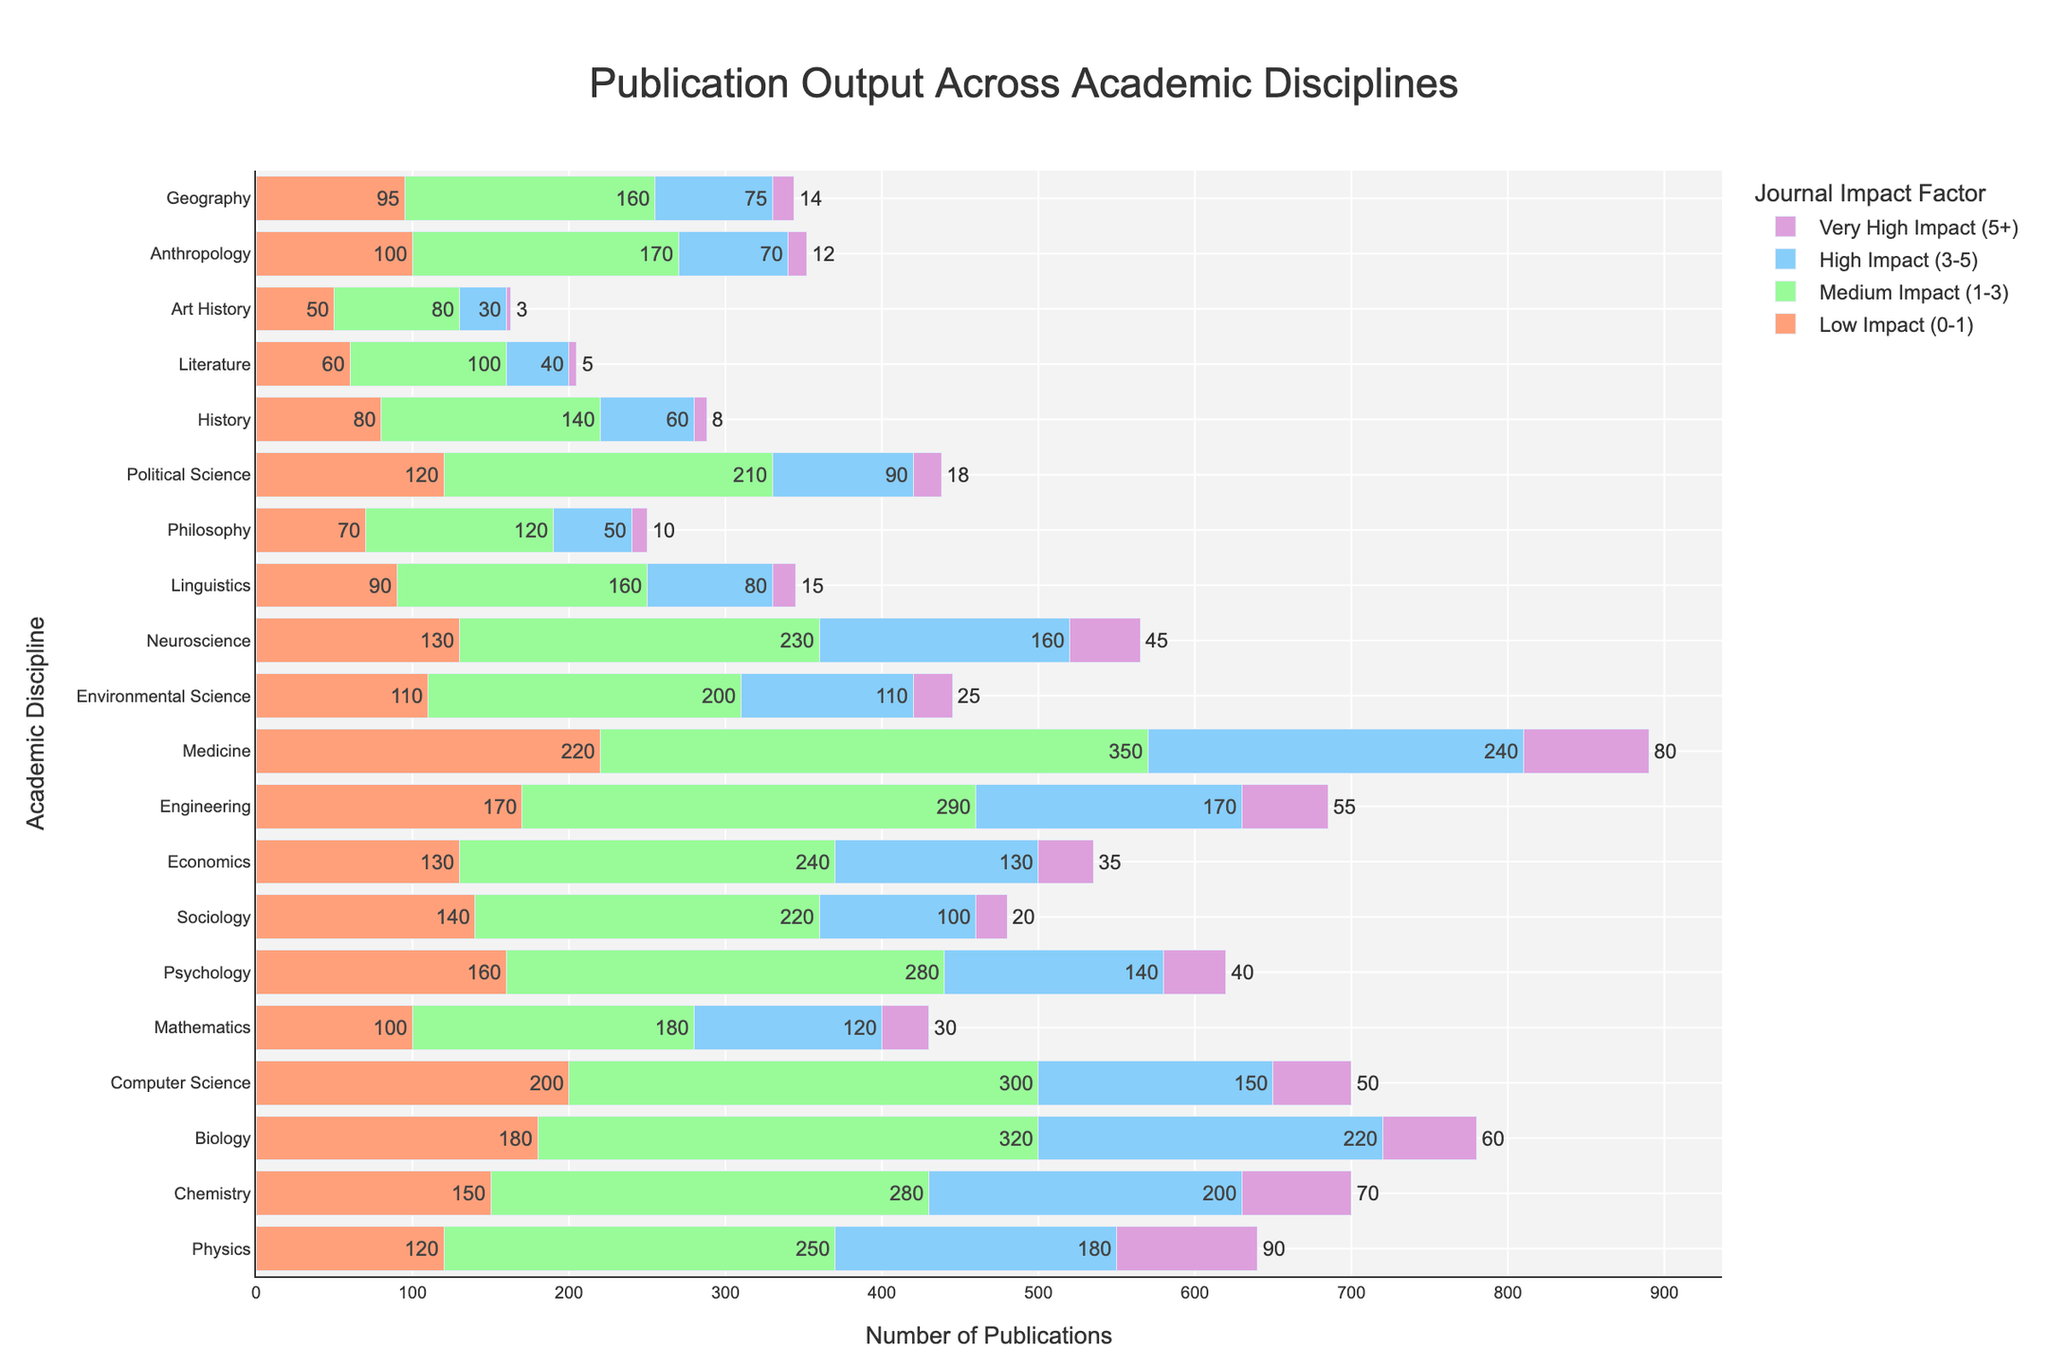What's the academic discipline with the highest total number of publications? To find the academic discipline with the highest total number of publications, sum all the different impact factor categories for each discipline. Medicine has the highest total with 220 (Low Impact) + 350 (Medium Impact) + 240 (High Impact) + 80 (Very High Impact) = 890 publications.
Answer: Medicine Which two disciplines have the closest total number of publications? Sum the total number of publications for each discipline and identify the two with the closest sums. Physics has 120 + 250 + 180 + 90 = 640, and Computer Science has 200 + 300 + 150 + 50 = 700. The difference is 700 - 640 = 60 publications, which is closer than any other pairs.
Answer: Physics and Computer Science What percentage of Neuroscience publications are in high impact factor journals (3-5)? Calculate the proportion of high impact factor publications compared to total publications for Neuroscience: 160 (High Impact) / (130 + 230 + 160 + 45) * 100 = 160 / 565 * 100. Approximately 28.32%.
Answer: Approximately 28.32% Which impact factor category contains the highest number of publications overall? Sum the publications for each impact factor category across all disciplines. Medium Impact (1-3) has the highest total: 250 + 280 + 320 + 300 + 180 + 280 + 220 + 240 + 290 + 350 + 200 + 230 + 160 + 120 + 210 + 140 + 100 + 80 + 170 + 160 = 4960 publications.
Answer: Medium Impact (1-3) In which discipline does the "Very High Impact (5+)" category contribute the highest portion relative to its total publications? Calculate the proportion for each discipline by dividing "Very High Impact (5+)" publications by total publications in that discipline. For example, for Philosophy: 10 / (70 + 120 + 50 + 10) = 10 / 250 = 0.04. Repeat for all disciplines; Art History has the highest portion with 3 / 163 = approximately 0.018.
Answer: Art History Compare the total number of low impact publications (0-1) to high impact publications (3-5) across Medicine. Which category has more? Sum the respective categories for Medicine: 220 (Low Impact) and 240 (High Impact). Compare these sums: 240 (High Impact) is greater than 220 (Low Impact).
Answer: High Impact (3-5) Which discipline has the lowest number of very high impact (5+) publications? Identify the discipline with the lowest value in the "Very High Impact (5+)" category. Art History has the lowest with 3 publications.
Answer: Art History How many publications are there in total for disciplines with more than 200 very high impact publications? Identify disciplines where total of "Very High Impact (5+)" publications is greater than 200 and sum their publications. None of the disciplines have more than 200 publications in this category.
Answer: 0 Between Physics and Chemistry, which discipline has a greater number of medium impact publications (1-3)? Compare the values for medium impact publications: Physics has 250 and Chemistry has 280. Chemistry has more medium impact publications.
Answer: Chemistry What's the overall percentage of low impact (0-1) publications across all disciplines? Calculate the total number of low impact publications and divide by the total number of all publications: (sum of Low Impact (0-1) across all disciplines) / (sum of all categories across all disciplines) * 100. 120 + 150 + 180 + 200 + 100 + 160 + 140 + 130 + 170 + 220 + 110 + 130 + 90 + 70 + 120 + 80 + 60 + 50 + 100 + 95 = 2585 /(2585 + 4960 + 2535 + 692) = 2585 / 10772 * 100 ≈ 23.99%.
Answer: Approximately 23.99% 